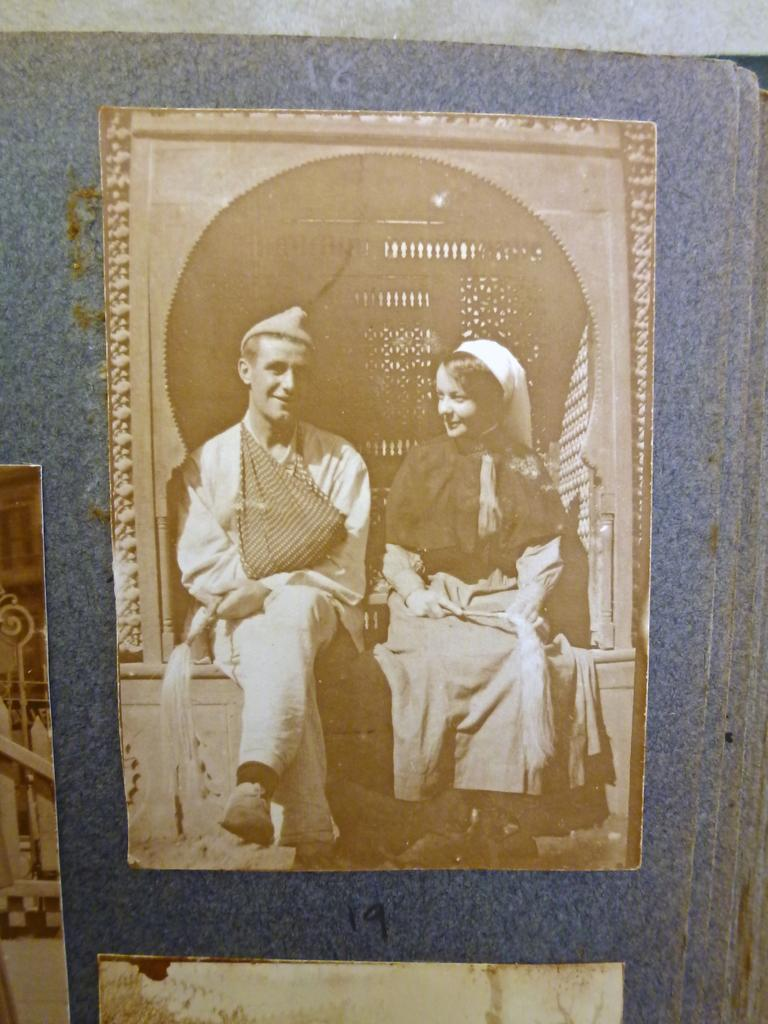What is the main subject of the image? The main subject of the image is a photo. What can be seen in the photo? The photo contains persons. What are the persons in the photo wearing? The persons in the photo are wearing clothes. What type of roll can be seen on the ground in the image? There is no roll visible on the ground in the image; it only contains a photo with persons wearing clothes. 